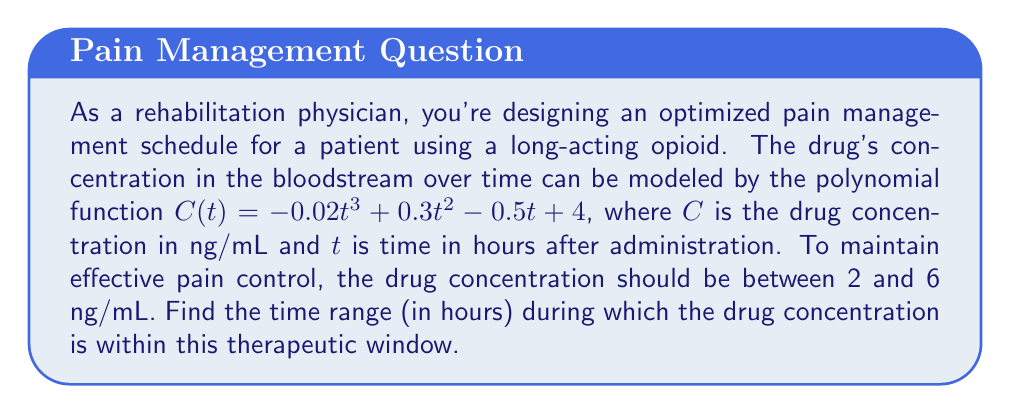Show me your answer to this math problem. To solve this problem, we need to find the values of $t$ where $C(t) = 2$ and $C(t) = 6$. These points will define the boundaries of our therapeutic window.

1. Set up the equations:
   $$-0.02t^3 + 0.3t^2 - 0.5t + 4 = 2$$
   $$-0.02t^3 + 0.3t^2 - 0.5t + 4 = 6$$

2. Simplify the equations:
   $$-0.02t^3 + 0.3t^2 - 0.5t + 2 = 0$$
   $$-0.02t^3 + 0.3t^2 - 0.5t - 2 = 0$$

3. These cubic equations are difficult to solve by hand, so we'll use a graphing calculator or computer algebra system to find the roots.

4. For the equation $-0.02t^3 + 0.3t^2 - 0.5t + 2 = 0$, we get:
   $t \approx 0.37$ and $t \approx 8.63$ (ignoring the negative root)

5. For the equation $-0.02t^3 + 0.3t^2 - 0.5t - 2 = 0$, we get:
   $t \approx 5.37$ (ignoring the negative and large positive roots)

6. The therapeutic window is between the smallest and largest of these values:
   $0.37 < t < 8.63$

7. Round to two decimal places for practical use:
   $0.37 \leq t \leq 8.63$

This means the drug concentration is within the therapeutic window from 0.37 hours to 8.63 hours after administration.
Answer: $[0.37, 8.63]$ hours 